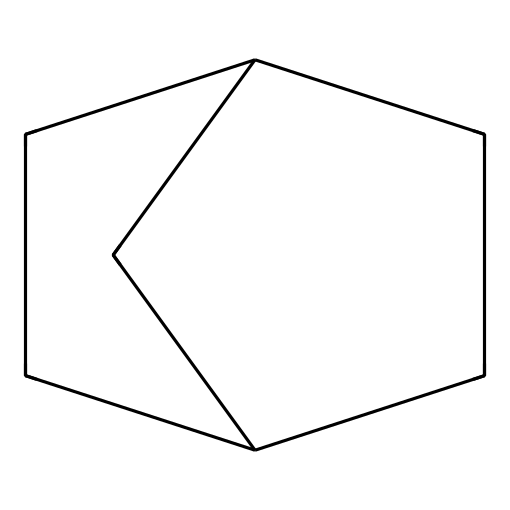What is the molecular formula of norbornane? To determine the molecular formula, count the number of carbon and hydrogen atoms in the chemical structure. From the SMILES, there are 10 carbon atoms and 16 hydrogen atoms, creating the formula C10H16.
Answer: C10H16 How many rings are present in norbornane? Norbornane contains two fused cyclopentane rings, which can be identified from the bicyclic structure in the SMILES code, indicating one combined ring system.
Answer: 2 What type of compound is norbornane classified as? Norbornane is a bicyclic alkane, which can be deduced from its structure that features multiple carbon cycles with saturated bonds, typical of alkanes.
Answer: bicyclic alkane What is the total number of hydrogen atoms in norbornane? By examining the molecular formula C10H16 determined from the structure, you can directly see that norbornane has a total of 16 hydrogen atoms.
Answer: 16 Why is norbornane significant in the production of polymers? The structure of norbornane allows for reactivity in creating chain and branched polymers due to its unique bicyclic form, which contributes to the physical properties required in industrial applications.
Answer: reactivity 